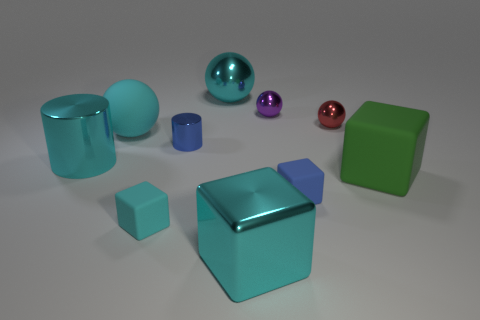Subtract all large cyan shiny cubes. How many cubes are left? 3 Subtract all cylinders. How many objects are left? 8 Subtract all cyan blocks. How many blocks are left? 2 Subtract 3 spheres. How many spheres are left? 1 Add 4 metal balls. How many metal balls exist? 7 Subtract 0 brown spheres. How many objects are left? 10 Subtract all green cylinders. Subtract all green cubes. How many cylinders are left? 2 Subtract all blue cylinders. How many brown blocks are left? 0 Subtract all tiny green metallic spheres. Subtract all large rubber balls. How many objects are left? 9 Add 3 big cyan balls. How many big cyan balls are left? 5 